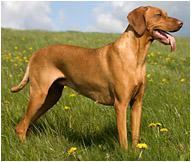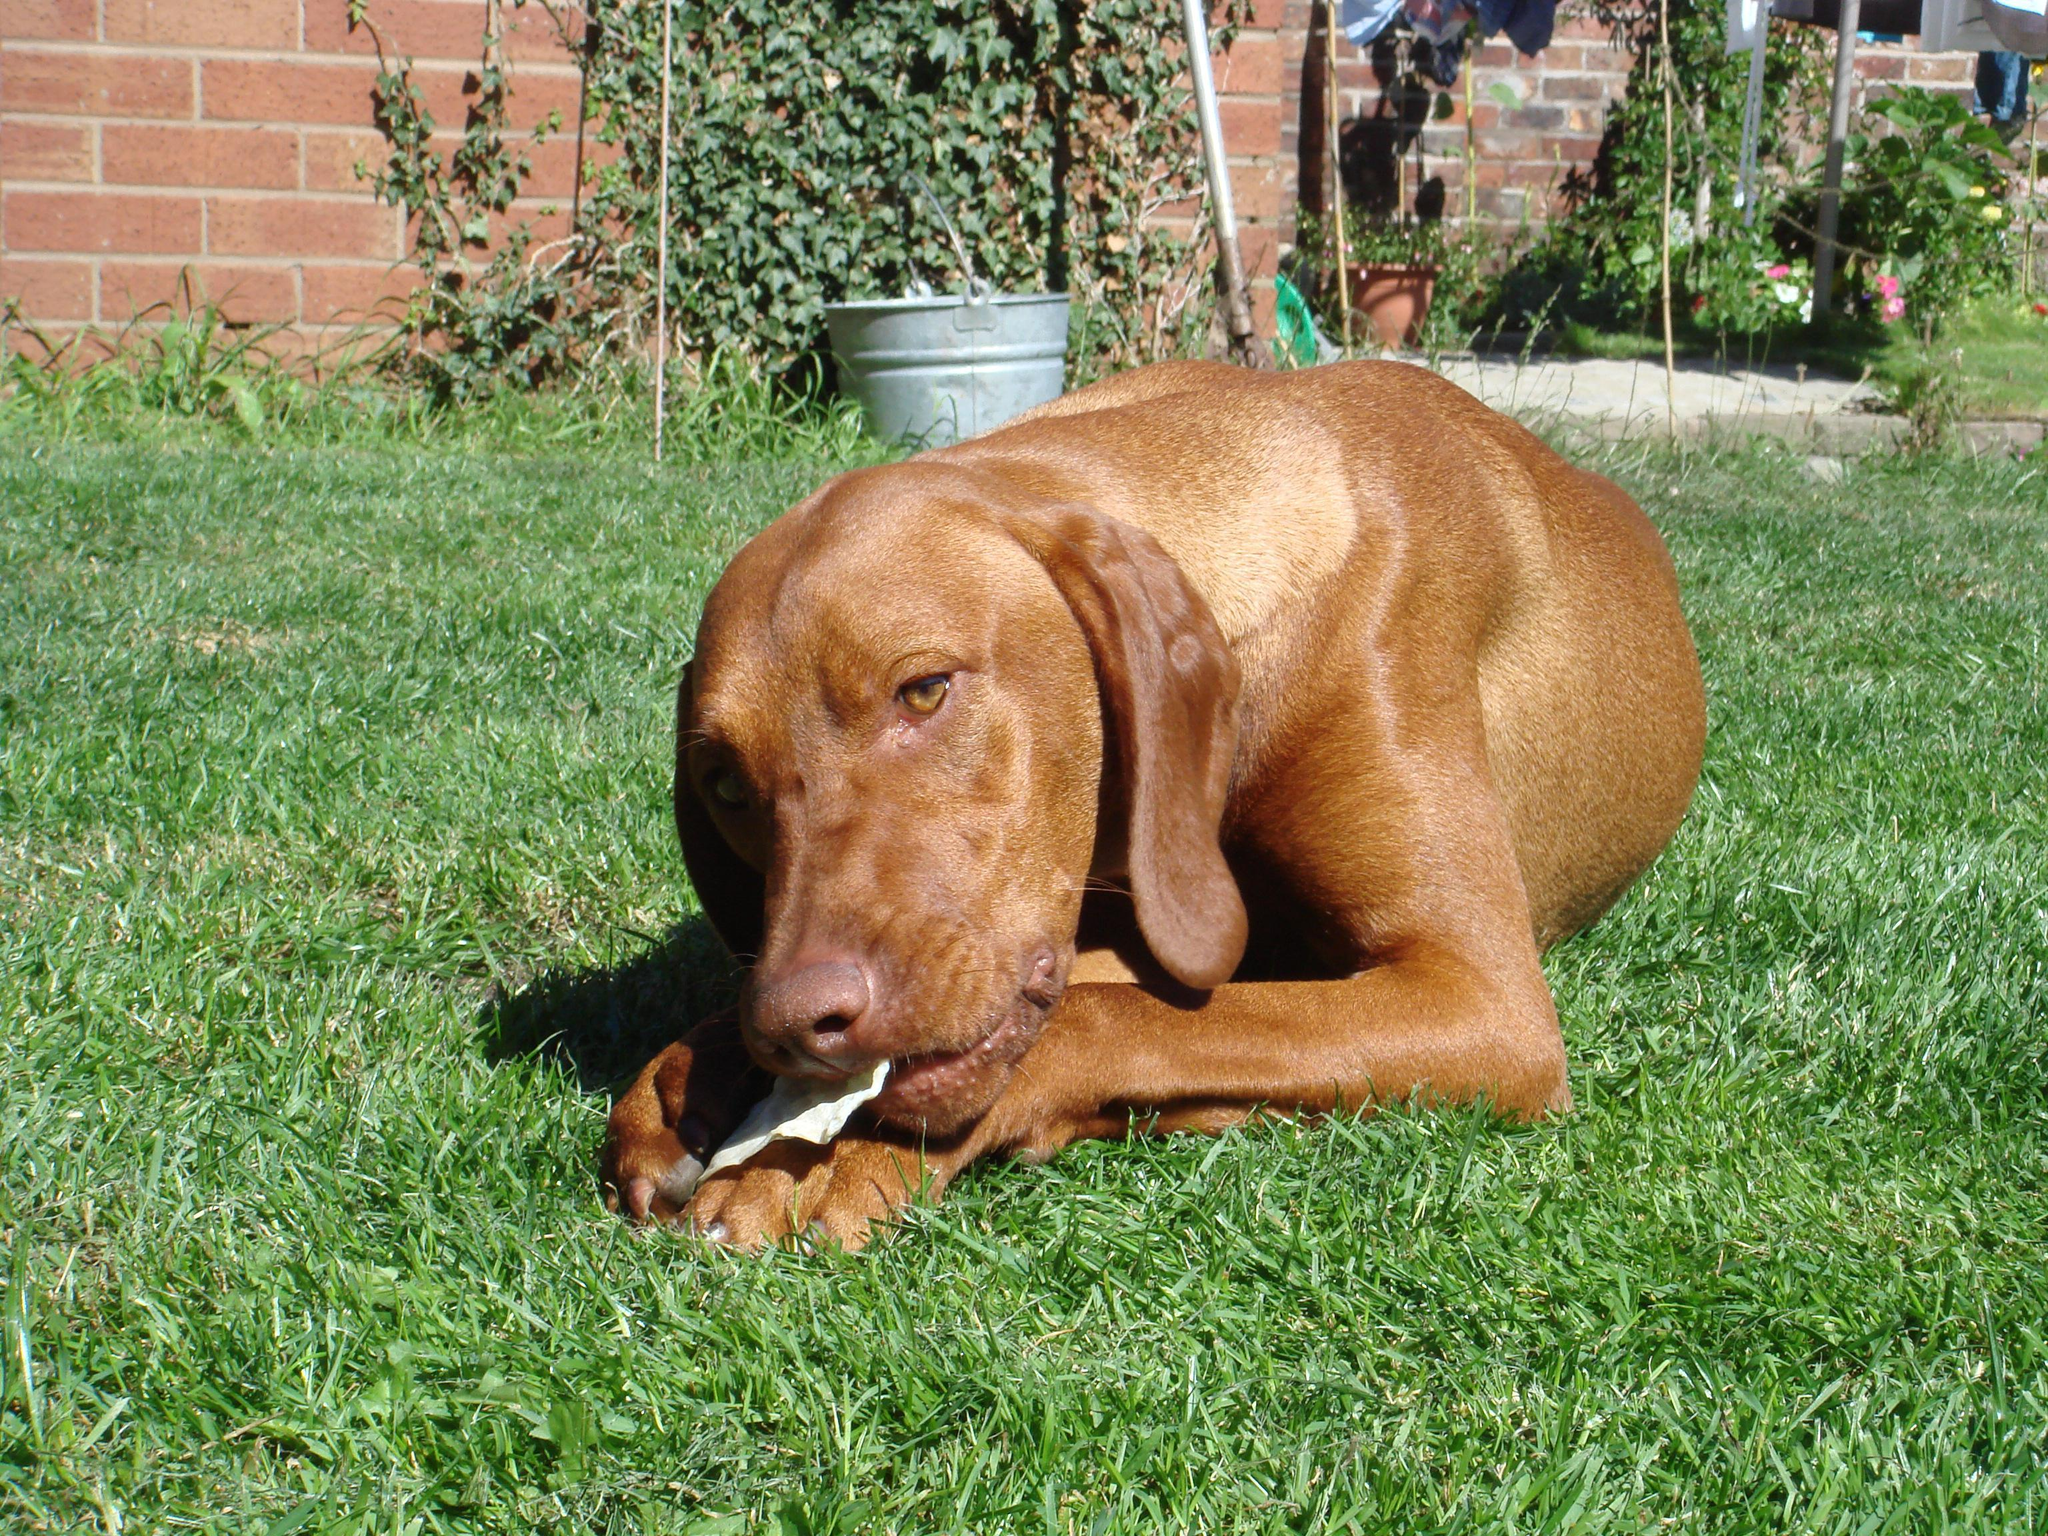The first image is the image on the left, the second image is the image on the right. Analyze the images presented: Is the assertion "A dog has something in its mouth in the right image." valid? Answer yes or no. Yes. 